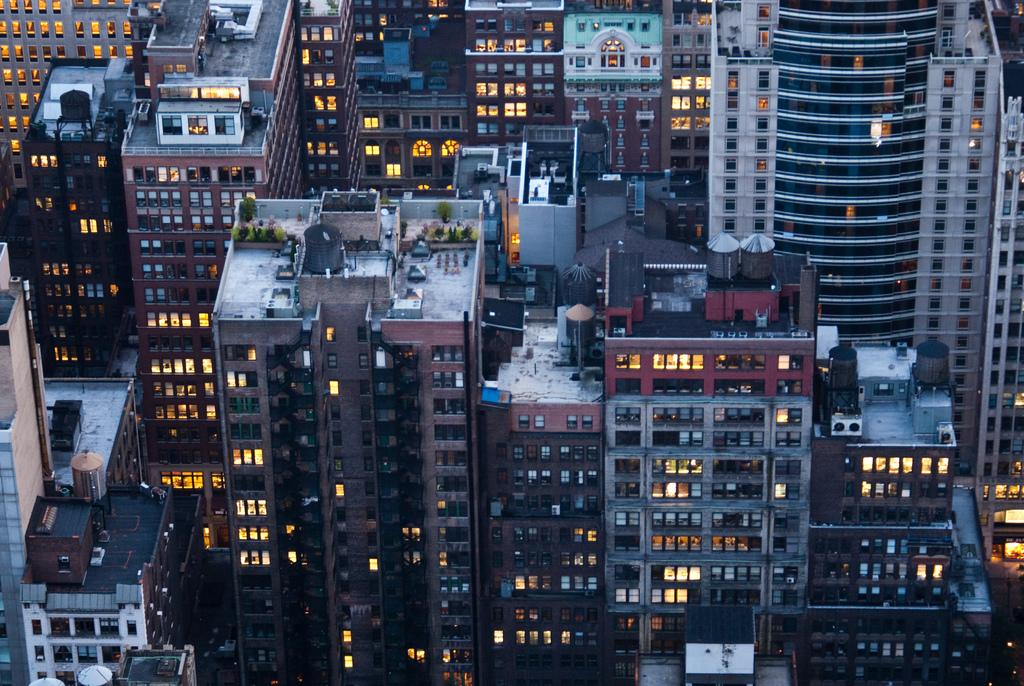What is located in the center of the image? There are buildings and towers in the center of the image. What feature do the buildings and towers have? The buildings and towers have windows. What can be seen in the image that provides illumination? There are lights visible in the image. What type of vegetation is present in the image? There are plants in the image. What other structures can be seen in the image? There are water tanks in the image. Are there any other objects visible in the image? Yes, there are a few other objects in the image. What type of mark can be seen on the whistle in the image? There is no whistle present in the image, so it is not possible to determine if there is a mark on it. 